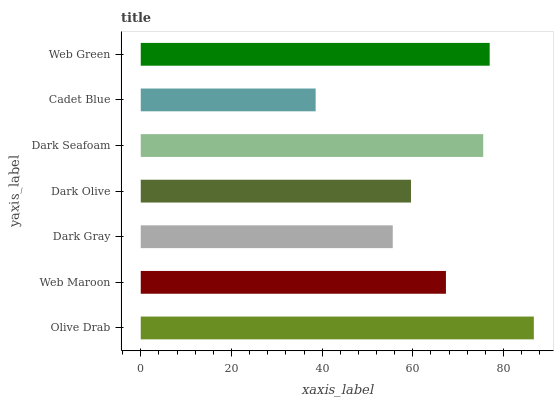Is Cadet Blue the minimum?
Answer yes or no. Yes. Is Olive Drab the maximum?
Answer yes or no. Yes. Is Web Maroon the minimum?
Answer yes or no. No. Is Web Maroon the maximum?
Answer yes or no. No. Is Olive Drab greater than Web Maroon?
Answer yes or no. Yes. Is Web Maroon less than Olive Drab?
Answer yes or no. Yes. Is Web Maroon greater than Olive Drab?
Answer yes or no. No. Is Olive Drab less than Web Maroon?
Answer yes or no. No. Is Web Maroon the high median?
Answer yes or no. Yes. Is Web Maroon the low median?
Answer yes or no. Yes. Is Olive Drab the high median?
Answer yes or no. No. Is Dark Olive the low median?
Answer yes or no. No. 